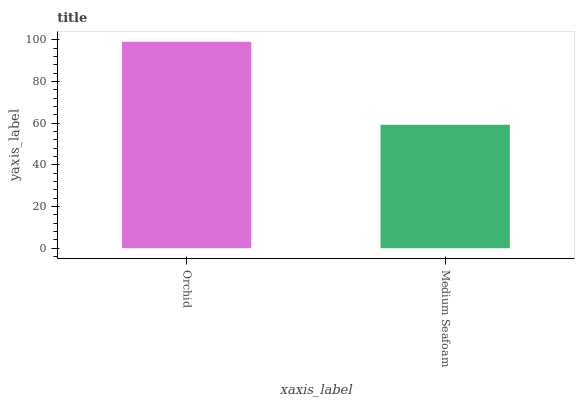Is Medium Seafoam the minimum?
Answer yes or no. Yes. Is Orchid the maximum?
Answer yes or no. Yes. Is Medium Seafoam the maximum?
Answer yes or no. No. Is Orchid greater than Medium Seafoam?
Answer yes or no. Yes. Is Medium Seafoam less than Orchid?
Answer yes or no. Yes. Is Medium Seafoam greater than Orchid?
Answer yes or no. No. Is Orchid less than Medium Seafoam?
Answer yes or no. No. Is Orchid the high median?
Answer yes or no. Yes. Is Medium Seafoam the low median?
Answer yes or no. Yes. Is Medium Seafoam the high median?
Answer yes or no. No. Is Orchid the low median?
Answer yes or no. No. 